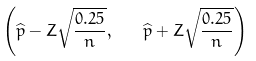<formula> <loc_0><loc_0><loc_500><loc_500>\left ( { \widehat { p } } - Z { \sqrt { \frac { 0 . 2 5 } { n } } } , \quad \widehat { p } + Z { \sqrt { \frac { 0 . 2 5 } { n } } } \right )</formula> 